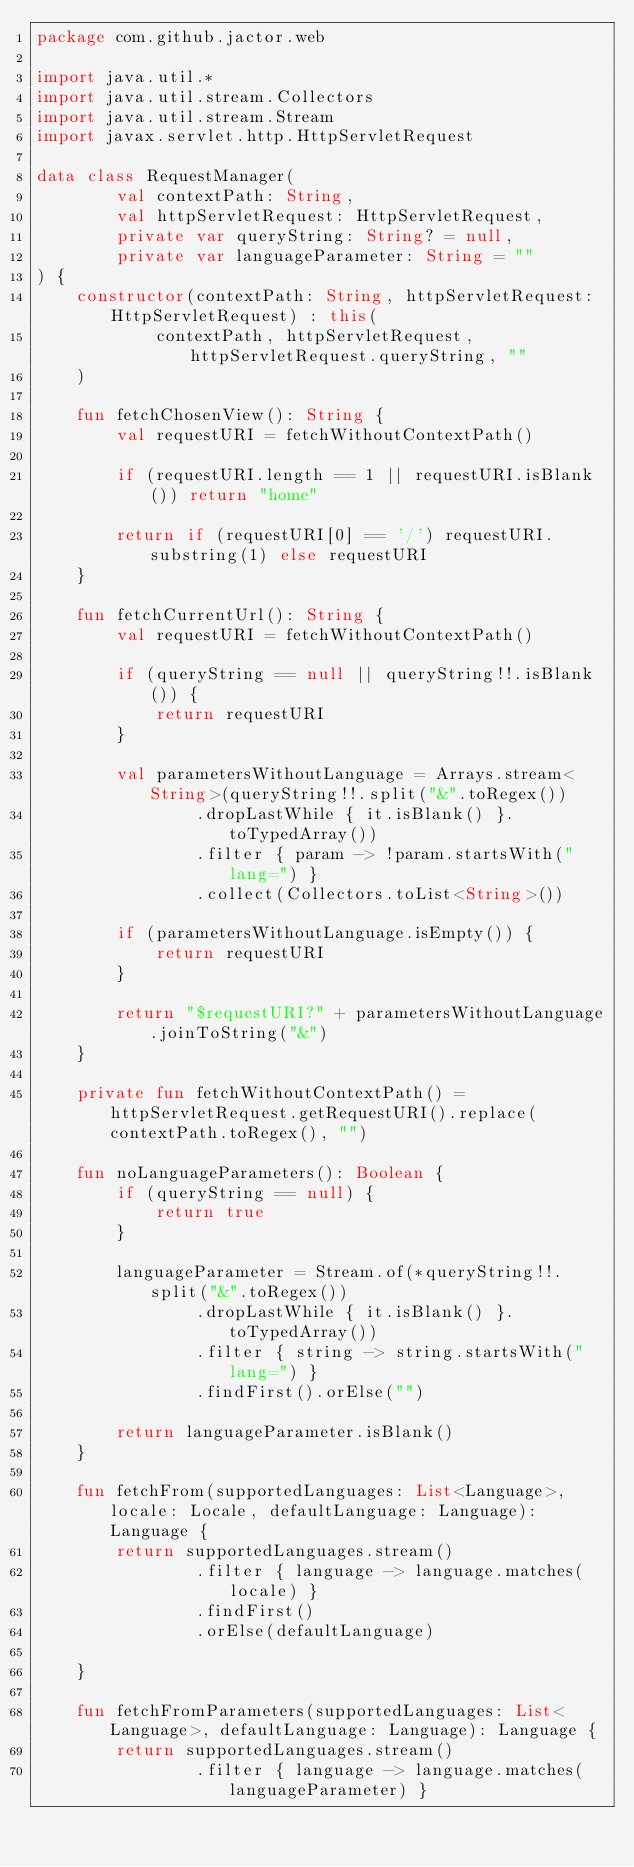<code> <loc_0><loc_0><loc_500><loc_500><_Kotlin_>package com.github.jactor.web

import java.util.*
import java.util.stream.Collectors
import java.util.stream.Stream
import javax.servlet.http.HttpServletRequest

data class RequestManager(
        val contextPath: String,
        val httpServletRequest: HttpServletRequest,
        private var queryString: String? = null,
        private var languageParameter: String = ""
) {
    constructor(contextPath: String, httpServletRequest: HttpServletRequest) : this(
            contextPath, httpServletRequest, httpServletRequest.queryString, ""
    )

    fun fetchChosenView(): String {
        val requestURI = fetchWithoutContextPath()

        if (requestURI.length == 1 || requestURI.isBlank()) return "home"

        return if (requestURI[0] == '/') requestURI.substring(1) else requestURI
    }

    fun fetchCurrentUrl(): String {
        val requestURI = fetchWithoutContextPath()

        if (queryString == null || queryString!!.isBlank()) {
            return requestURI
        }

        val parametersWithoutLanguage = Arrays.stream<String>(queryString!!.split("&".toRegex())
                .dropLastWhile { it.isBlank() }.toTypedArray())
                .filter { param -> !param.startsWith("lang=") }
                .collect(Collectors.toList<String>())

        if (parametersWithoutLanguage.isEmpty()) {
            return requestURI
        }

        return "$requestURI?" + parametersWithoutLanguage.joinToString("&")
    }

    private fun fetchWithoutContextPath() = httpServletRequest.getRequestURI().replace(contextPath.toRegex(), "")

    fun noLanguageParameters(): Boolean {
        if (queryString == null) {
            return true
        }

        languageParameter = Stream.of(*queryString!!.split("&".toRegex())
                .dropLastWhile { it.isBlank() }.toTypedArray())
                .filter { string -> string.startsWith("lang=") }
                .findFirst().orElse("")

        return languageParameter.isBlank()
    }

    fun fetchFrom(supportedLanguages: List<Language>, locale: Locale, defaultLanguage: Language): Language {
        return supportedLanguages.stream()
                .filter { language -> language.matches(locale) }
                .findFirst()
                .orElse(defaultLanguage)

    }

    fun fetchFromParameters(supportedLanguages: List<Language>, defaultLanguage: Language): Language {
        return supportedLanguages.stream()
                .filter { language -> language.matches(languageParameter) }</code> 